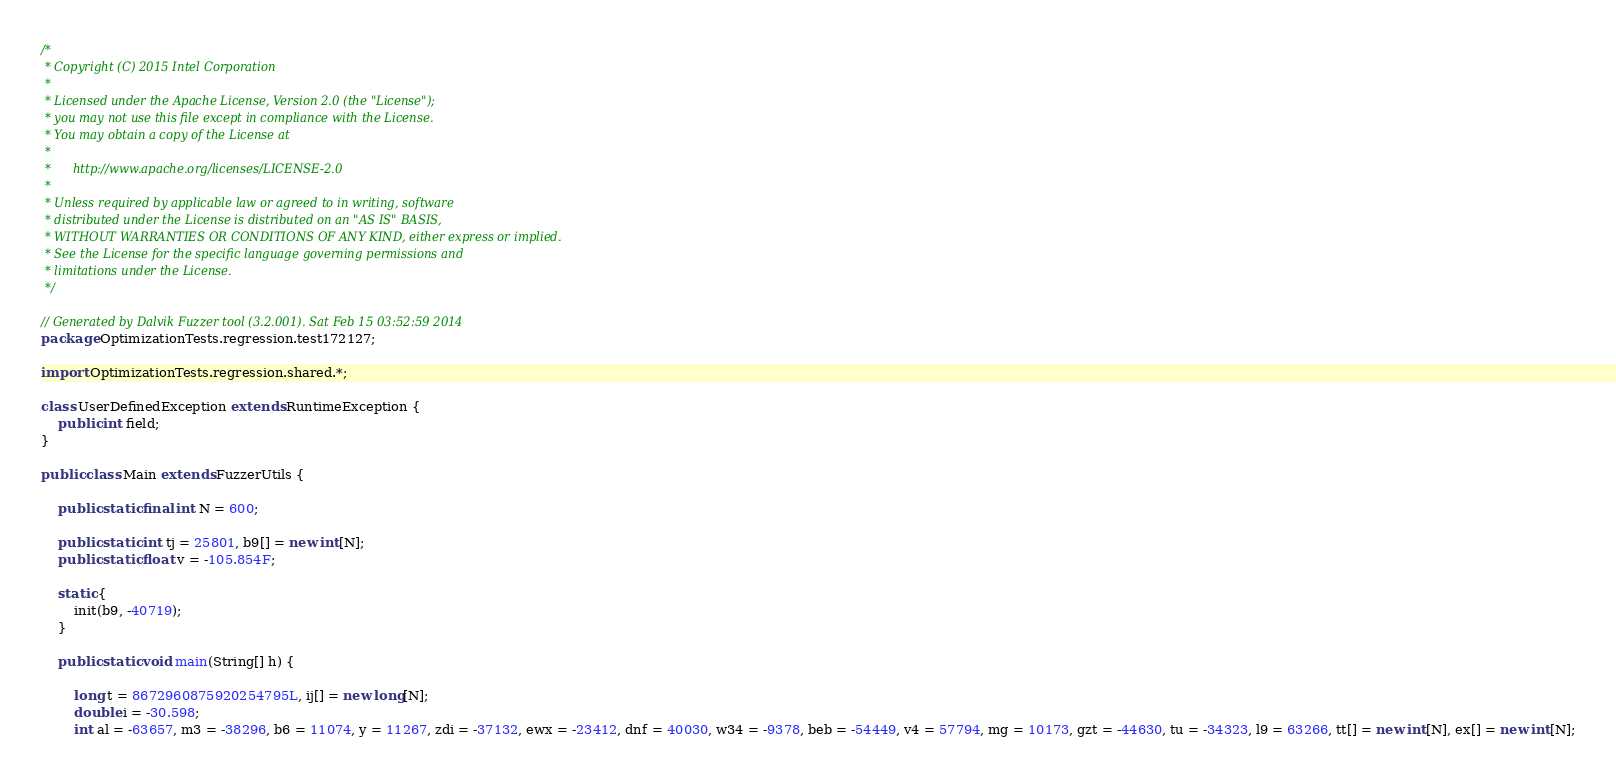Convert code to text. <code><loc_0><loc_0><loc_500><loc_500><_Java_>/*
 * Copyright (C) 2015 Intel Corporation
 *
 * Licensed under the Apache License, Version 2.0 (the "License");
 * you may not use this file except in compliance with the License.
 * You may obtain a copy of the License at
 *
 *      http://www.apache.org/licenses/LICENSE-2.0
 *
 * Unless required by applicable law or agreed to in writing, software
 * distributed under the License is distributed on an "AS IS" BASIS,
 * WITHOUT WARRANTIES OR CONDITIONS OF ANY KIND, either express or implied.
 * See the License for the specific language governing permissions and
 * limitations under the License.
 */

// Generated by Dalvik Fuzzer tool (3.2.001). Sat Feb 15 03:52:59 2014
package OptimizationTests.regression.test172127;

import OptimizationTests.regression.shared.*;

class UserDefinedException extends RuntimeException {
    public int field;
}

public class Main extends FuzzerUtils {

    public static final int N = 600;

    public static int tj = 25801, b9[] = new int[N];
    public static float v = -105.854F;

    static {
        init(b9, -40719);
    }

    public static void main(String[] h) {

        long t = 8672960875920254795L, ij[] = new long[N];
        double i = -30.598;
        int al = -63657, m3 = -38296, b6 = 11074, y = 11267, zdi = -37132, ewx = -23412, dnf = 40030, w34 = -9378, beb = -54449, v4 = 57794, mg = 10173, gzt = -44630, tu = -34323, l9 = 63266, tt[] = new int[N], ex[] = new int[N];</code> 